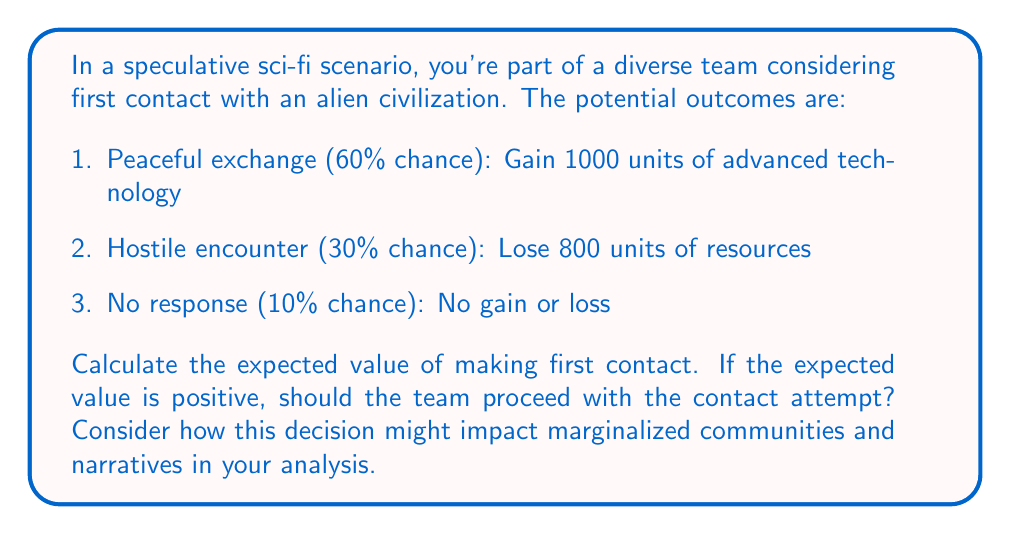Provide a solution to this math problem. To solve this problem, we'll use the concept of expected value from decision theory. The expected value is calculated by multiplying each possible outcome by its probability and then summing these products.

Let's break it down step-by-step:

1. Peaceful exchange:
   Probability: 60% = 0.60
   Outcome: Gain 1000 units
   Expected value: $0.60 \times 1000 = 600$ units

2. Hostile encounter:
   Probability: 30% = 0.30
   Outcome: Lose 800 units
   Expected value: $0.30 \times (-800) = -240$ units

3. No response:
   Probability: 10% = 0.10
   Outcome: 0 units
   Expected value: $0.10 \times 0 = 0$ units

Now, we sum these expected values:

$$\text{Total Expected Value} = 600 + (-240) + 0 = 360\text{ units}$$

The expected value is positive, which suggests that, purely from a mathematical standpoint, the team should proceed with the contact attempt.

However, as a queer writer of color introducing fresh perspectives in science fiction, it's crucial to consider the broader implications of this decision:

1. Impact on marginalized communities: How might first contact affect already marginalized groups on Earth? Would they benefit equally from advanced technology, or could it exacerbate existing inequalities?

2. Diverse narratives: How does this decision challenge or reinforce traditional sci-fi narratives about first contact? Is there an opportunity to explore unique cultural exchanges or conflicts?

3. Risk distribution: Are the risks and potential benefits of first contact evenly distributed across all communities, or do some groups bear a disproportionate burden?

4. Long-term consequences: Beyond the immediate outcomes, how might this decision shape the future of humanity, especially for underrepresented groups?

These considerations add depth to the mathematical analysis and highlight the importance of diverse perspectives in decision-making processes, especially in speculative scenarios with far-reaching consequences.
Answer: The expected value of making first contact is 360 units. While this positive value suggests proceeding with the contact attempt from a purely mathematical standpoint, the decision should be carefully weighed against potential impacts on marginalized communities and the opportunity to introduce fresh narratives in the realm of first contact scenarios. 